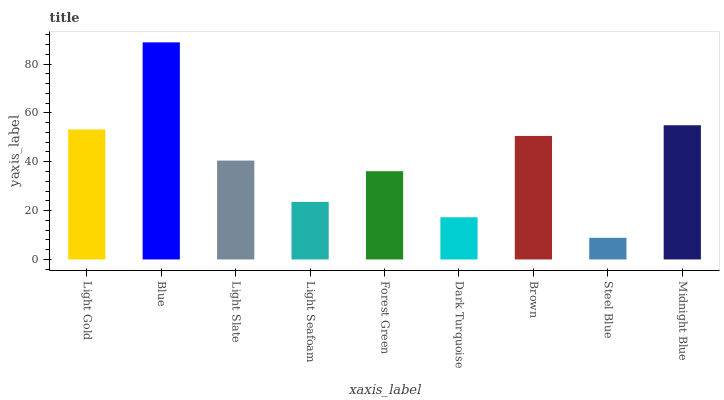Is Steel Blue the minimum?
Answer yes or no. Yes. Is Blue the maximum?
Answer yes or no. Yes. Is Light Slate the minimum?
Answer yes or no. No. Is Light Slate the maximum?
Answer yes or no. No. Is Blue greater than Light Slate?
Answer yes or no. Yes. Is Light Slate less than Blue?
Answer yes or no. Yes. Is Light Slate greater than Blue?
Answer yes or no. No. Is Blue less than Light Slate?
Answer yes or no. No. Is Light Slate the high median?
Answer yes or no. Yes. Is Light Slate the low median?
Answer yes or no. Yes. Is Forest Green the high median?
Answer yes or no. No. Is Light Seafoam the low median?
Answer yes or no. No. 